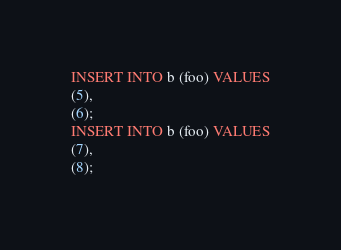<code> <loc_0><loc_0><loc_500><loc_500><_SQL_>INSERT INTO b (foo) VALUES
(5),
(6);
INSERT INTO b (foo) VALUES
(7),
(8);
</code> 